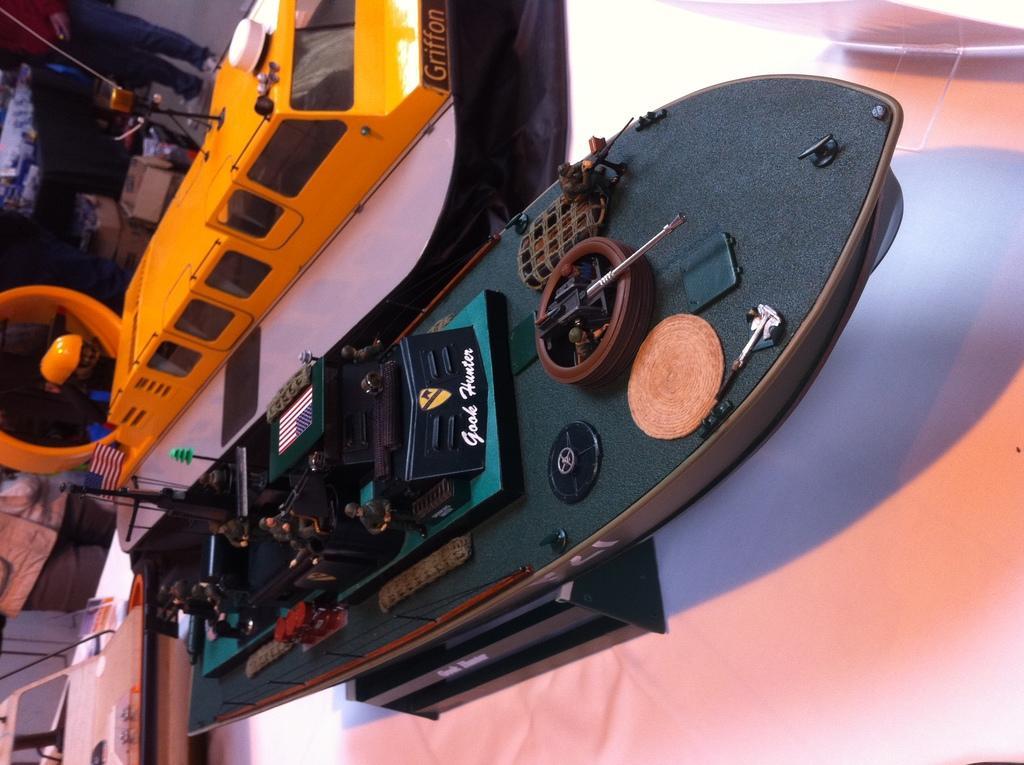Can you describe this image briefly? In this image we can see a boat, there is a ship, on a white surface, at the back there are carton boxes, there is a man standing on the ground. 